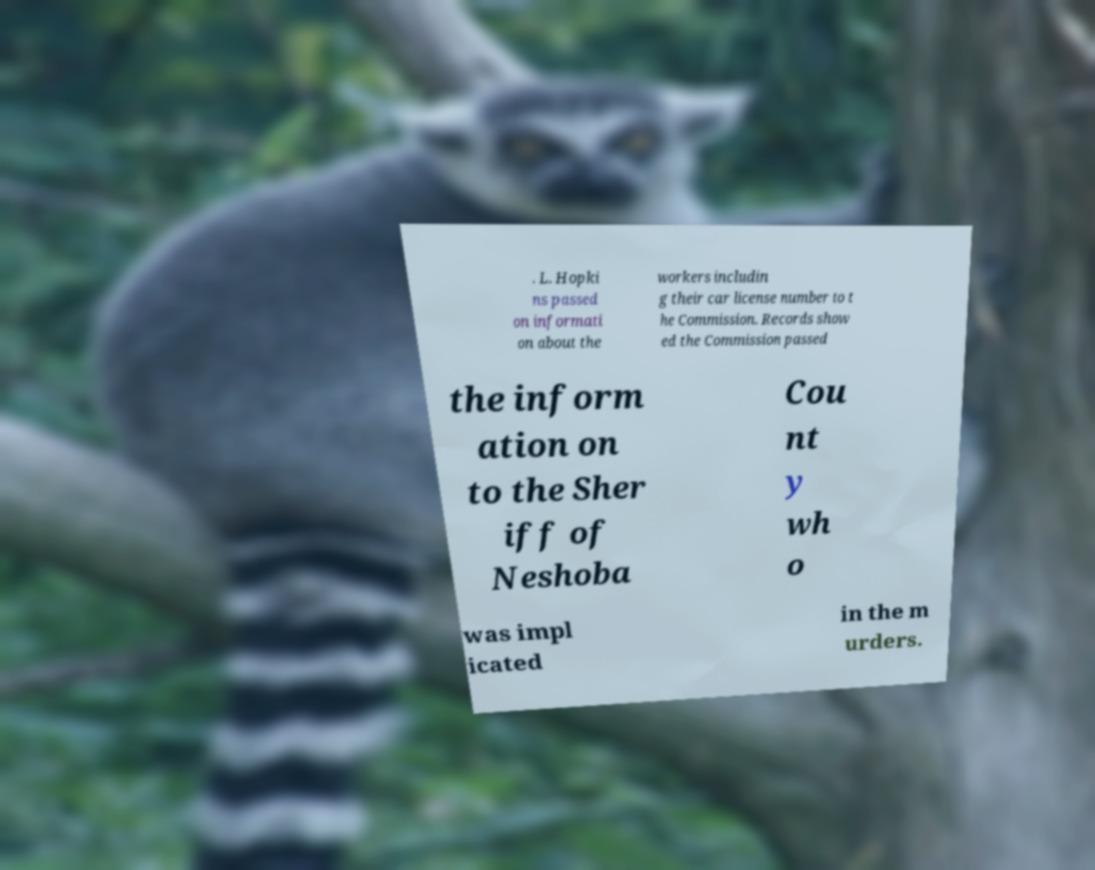Please read and relay the text visible in this image. What does it say? . L. Hopki ns passed on informati on about the workers includin g their car license number to t he Commission. Records show ed the Commission passed the inform ation on to the Sher iff of Neshoba Cou nt y wh o was impl icated in the m urders. 